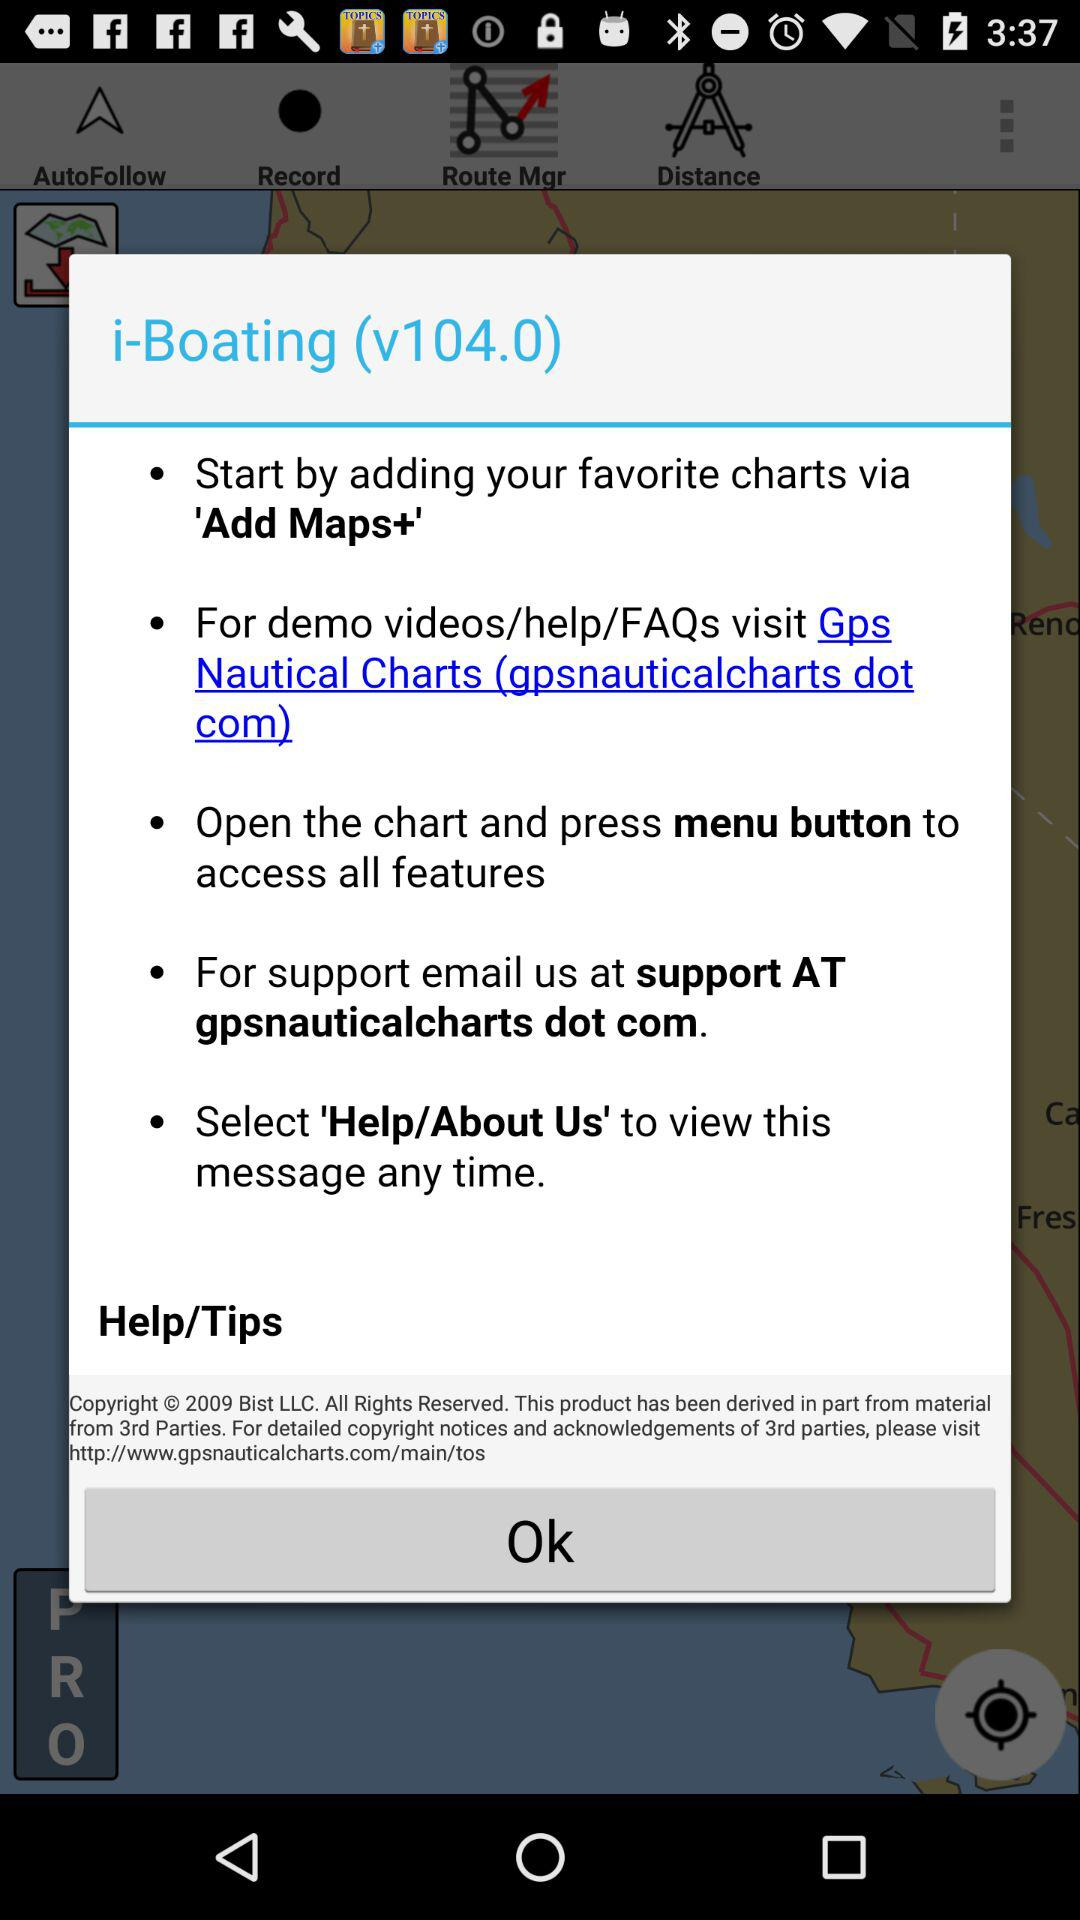What is the year of copyright for the application? The year of copyright for the application is 2009. 